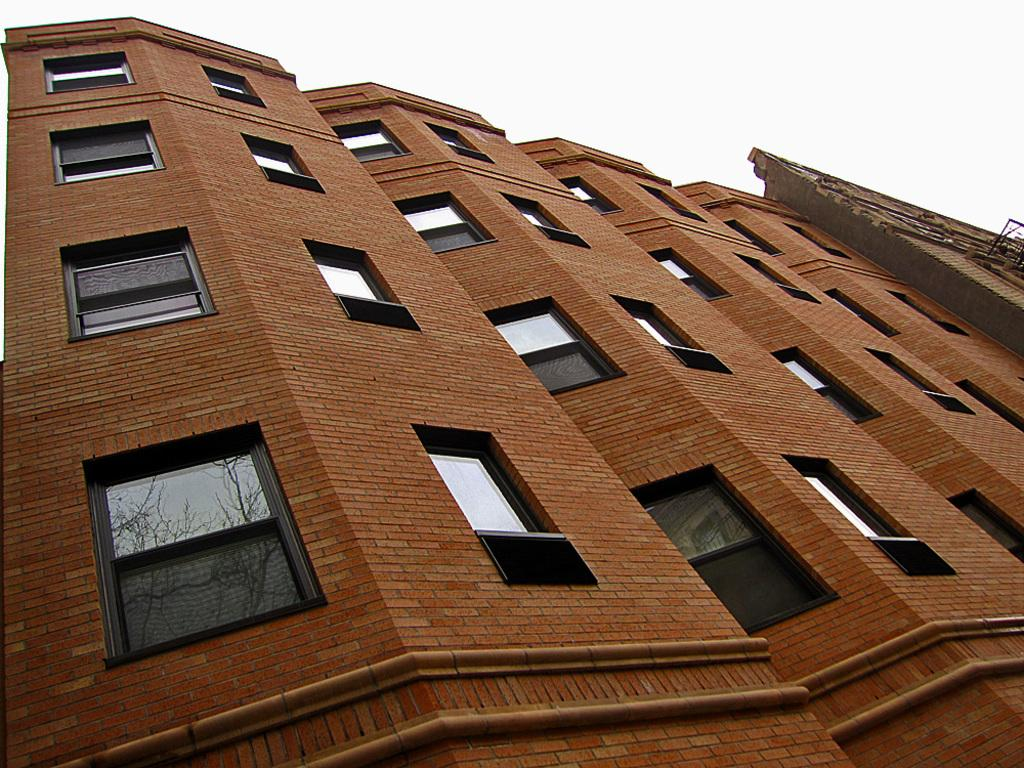How many buildings are present in the image? There are two buildings in the image. What feature do the buildings have in common? The buildings have many windows. What can be seen on the window glass of the buildings? There is a reflection of a tree on the window glass. What type of crack can be seen on the buildings in the image? There is no crack visible on the buildings in the image. 